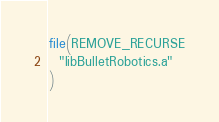Convert code to text. <code><loc_0><loc_0><loc_500><loc_500><_CMake_>file(REMOVE_RECURSE
  "libBulletRobotics.a"
)
</code> 